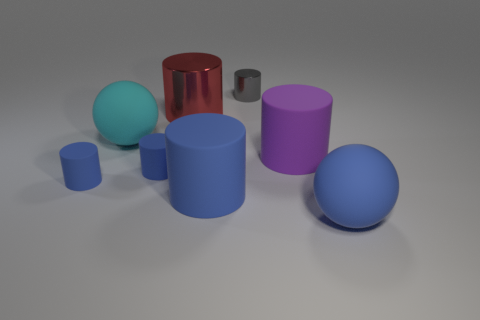Is the color of the large metallic thing the same as the large rubber object behind the big purple cylinder?
Offer a very short reply. No. Are there more blue matte spheres that are right of the gray metal thing than big red metallic objects?
Your answer should be compact. No. What number of large blue rubber objects are in front of the big blue matte object behind the sphere that is right of the gray thing?
Ensure brevity in your answer.  1. There is a metallic thing that is behind the red cylinder; is its shape the same as the large cyan matte thing?
Provide a short and direct response. No. What is the material of the small cylinder behind the purple rubber thing?
Make the answer very short. Metal. What is the shape of the small thing that is right of the large cyan thing and in front of the gray metallic object?
Give a very brief answer. Cylinder. Is the number of cyan spheres the same as the number of small green shiny objects?
Your answer should be compact. No. What is the large cyan object made of?
Give a very brief answer. Rubber. How many cylinders are either big blue things or tiny blue objects?
Offer a very short reply. 3. Are the cyan sphere and the blue sphere made of the same material?
Your answer should be very brief. Yes. 